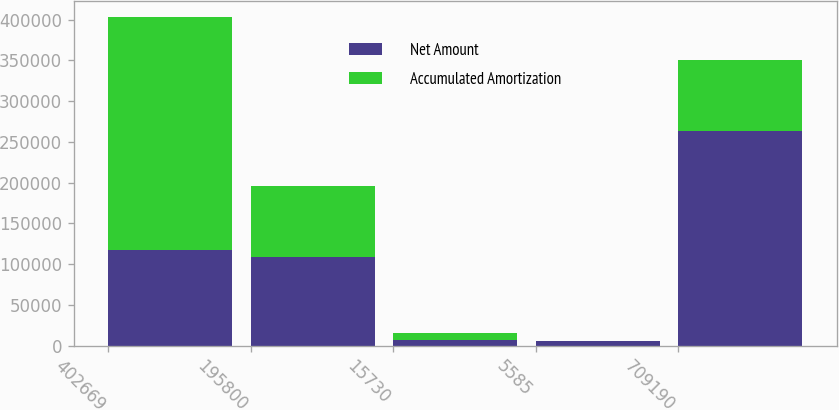Convert chart to OTSL. <chart><loc_0><loc_0><loc_500><loc_500><stacked_bar_chart><ecel><fcel>402669<fcel>195800<fcel>15730<fcel>5585<fcel>709190<nl><fcel>Net Amount<fcel>117222<fcel>109170<fcel>7118<fcel>5171<fcel>263691<nl><fcel>Accumulated Amortization<fcel>285447<fcel>86630<fcel>8612<fcel>414<fcel>86630<nl></chart> 